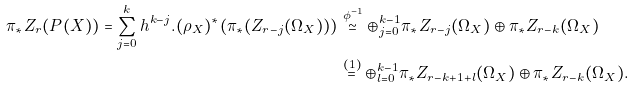Convert formula to latex. <formula><loc_0><loc_0><loc_500><loc_500>\pi _ { * } Z _ { r } ( P ( X ) ) = \sum _ { j = 0 } ^ { k } h ^ { k - j } . ( \rho _ { X } ) ^ { * } ( \pi _ { * } ( Z _ { r - j } ( \Omega _ { X } ) ) ) & \stackrel { \phi ^ { - 1 } } { \simeq } \oplus _ { j = 0 } ^ { k - 1 } \pi _ { * } Z _ { r - j } ( \Omega _ { X } ) \oplus \pi _ { * } Z _ { r - k } ( \Omega _ { X } ) \\ & \stackrel { ( 1 ) } { = } \oplus _ { l = 0 } ^ { k - 1 } \pi _ { * } Z _ { r - k + 1 + l } ( \Omega _ { X } ) \oplus \pi _ { * } Z _ { r - k } ( \Omega _ { X } ) .</formula> 